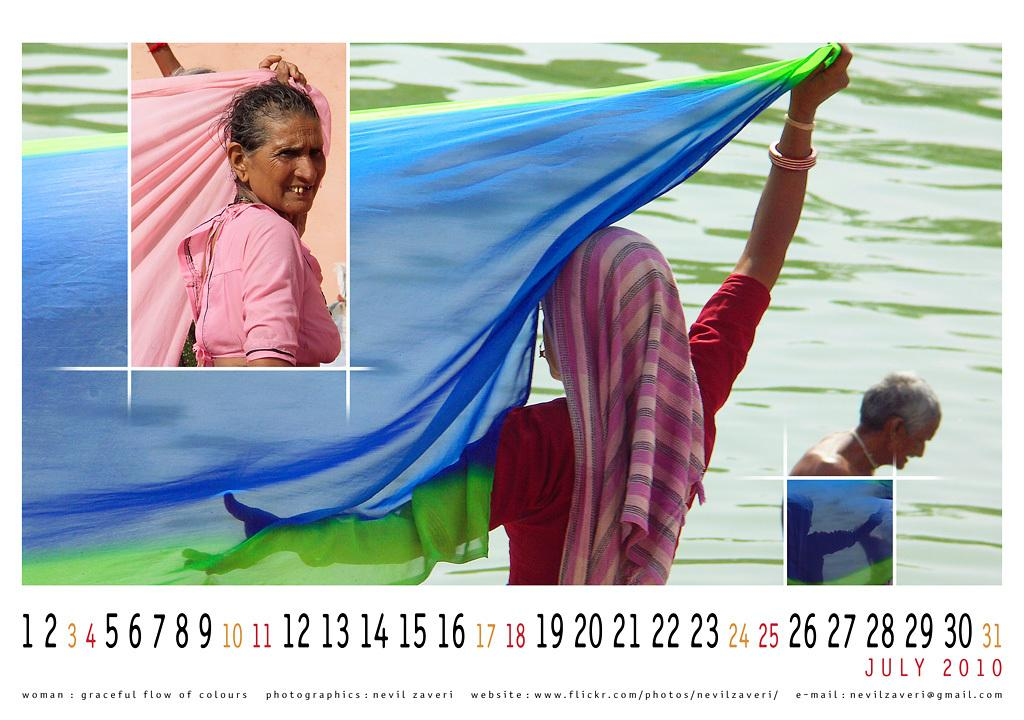What type of visual is the image? The image is a poster. How many people are depicted on the poster? There are three persons on the poster. Is there any text on the poster? Yes, there is text on the poster. What element is present in the image that is not related to the poster itself? There is water in the image. What type of base can be seen supporting the poster in the image? There is no base visible in the image, as it only shows the poster itself. What time of day is depicted in the image? The time of day cannot be determined from the image, as there are no specific indicators of day or night. 